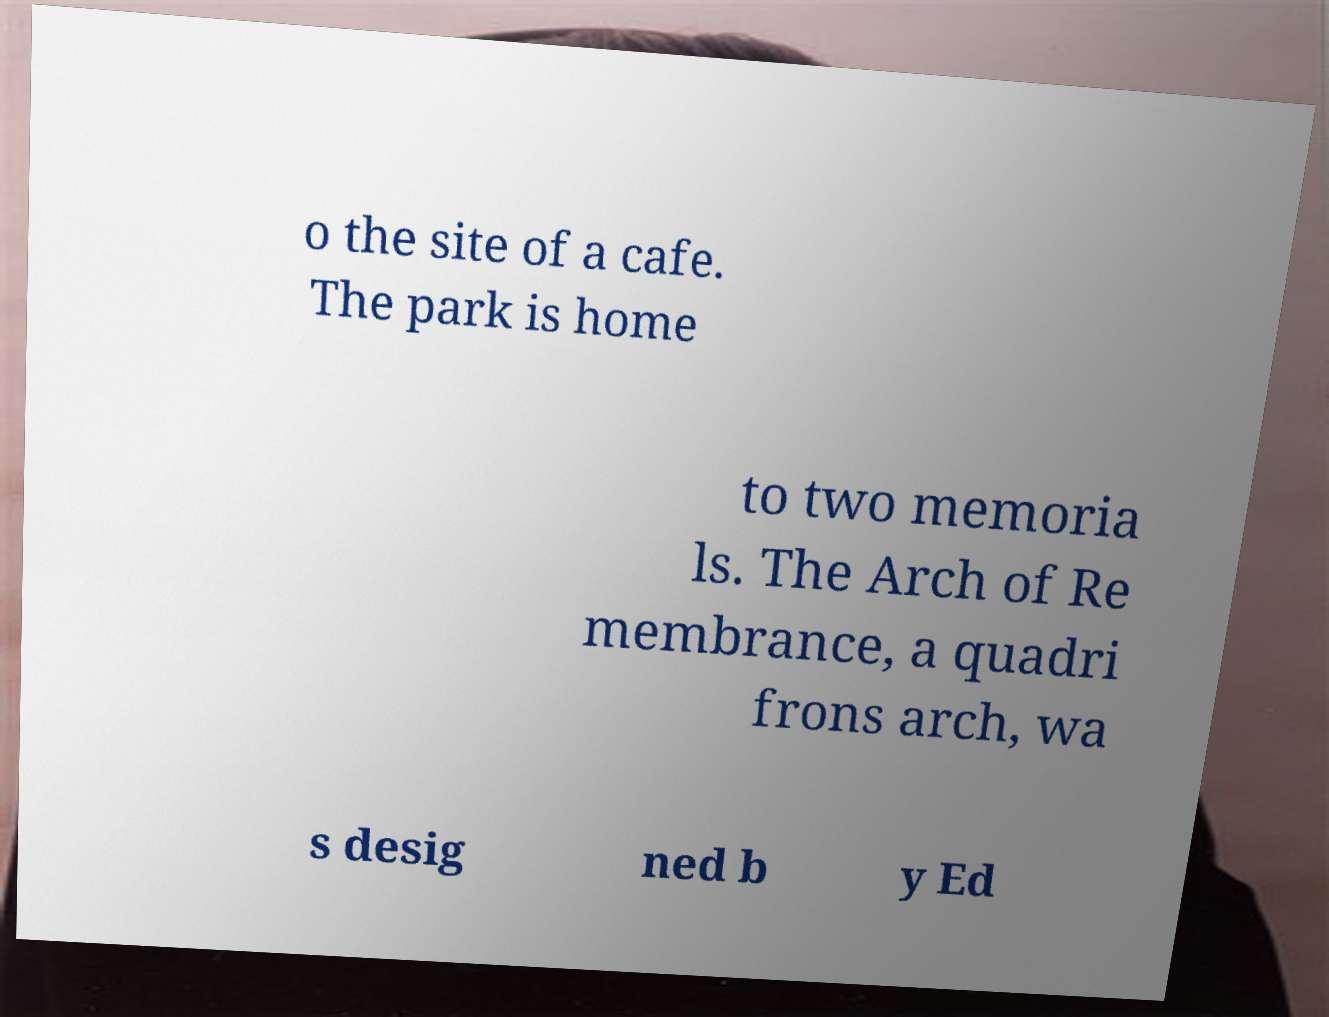What messages or text are displayed in this image? I need them in a readable, typed format. o the site of a cafe. The park is home to two memoria ls. The Arch of Re membrance, a quadri frons arch, wa s desig ned b y Ed 